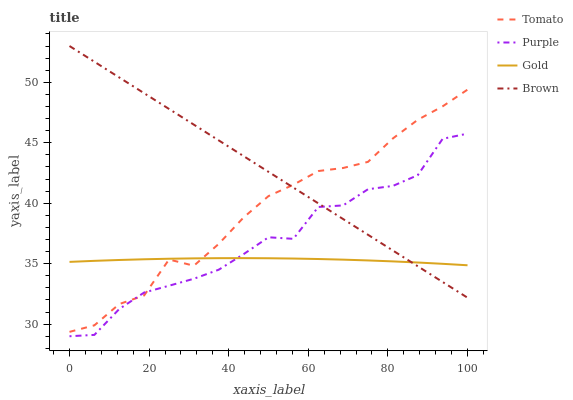Does Purple have the minimum area under the curve?
Answer yes or no. No. Does Purple have the maximum area under the curve?
Answer yes or no. No. Is Gold the smoothest?
Answer yes or no. No. Is Gold the roughest?
Answer yes or no. No. Does Gold have the lowest value?
Answer yes or no. No. Does Purple have the highest value?
Answer yes or no. No. 